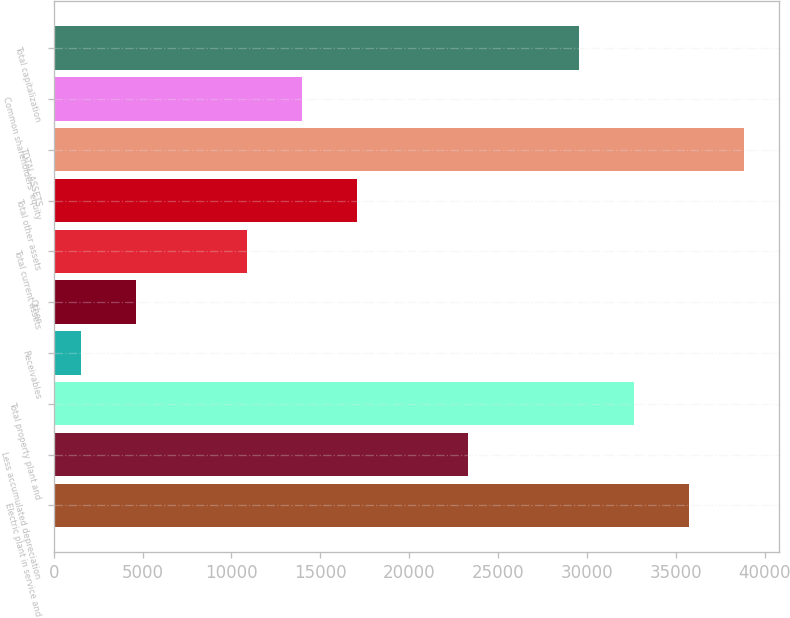Convert chart to OTSL. <chart><loc_0><loc_0><loc_500><loc_500><bar_chart><fcel>Electric plant in service and<fcel>Less accumulated depreciation<fcel>Total property plant and<fcel>Receivables<fcel>Other<fcel>Total current assets<fcel>Total other assets<fcel>TOTAL ASSETS<fcel>Common shareholders' equity<fcel>Total capitalization<nl><fcel>35749.8<fcel>23310.6<fcel>32640<fcel>1542<fcel>4651.8<fcel>10871.4<fcel>17091<fcel>38859.6<fcel>13981.2<fcel>29530.2<nl></chart> 